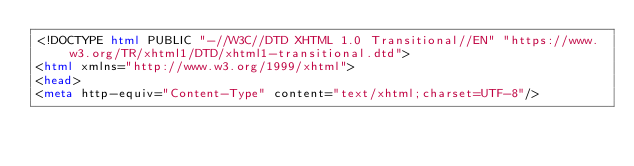<code> <loc_0><loc_0><loc_500><loc_500><_HTML_><!DOCTYPE html PUBLIC "-//W3C//DTD XHTML 1.0 Transitional//EN" "https://www.w3.org/TR/xhtml1/DTD/xhtml1-transitional.dtd">
<html xmlns="http://www.w3.org/1999/xhtml">
<head>
<meta http-equiv="Content-Type" content="text/xhtml;charset=UTF-8"/></code> 